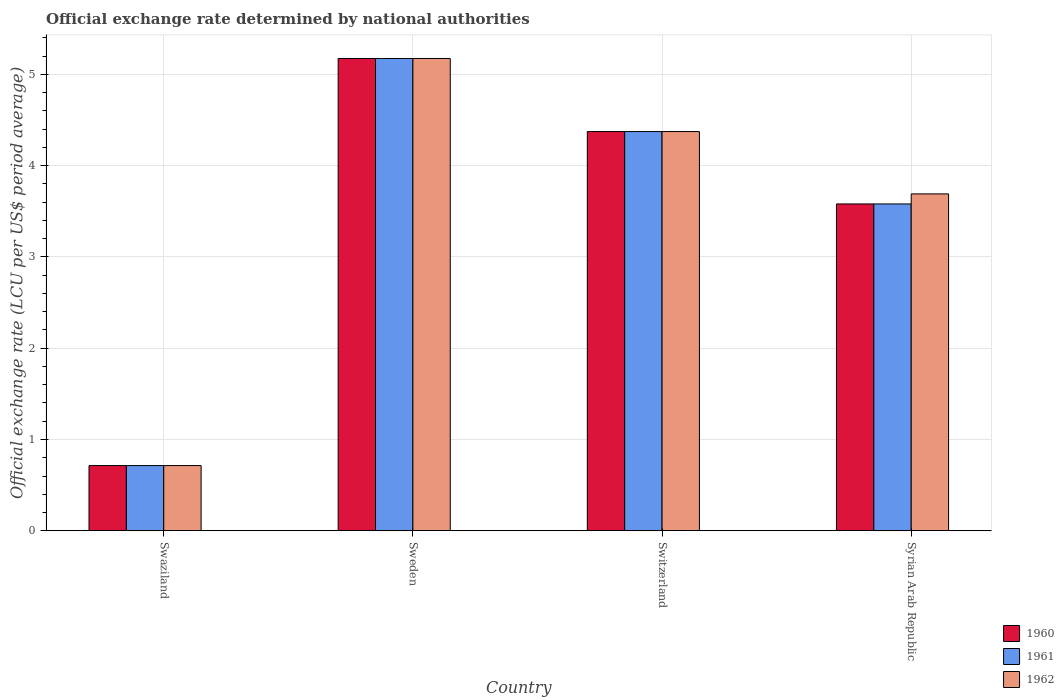Are the number of bars on each tick of the X-axis equal?
Give a very brief answer. Yes. How many bars are there on the 1st tick from the left?
Give a very brief answer. 3. How many bars are there on the 2nd tick from the right?
Give a very brief answer. 3. What is the official exchange rate in 1961 in Switzerland?
Provide a short and direct response. 4.37. Across all countries, what is the maximum official exchange rate in 1960?
Your answer should be very brief. 5.17. Across all countries, what is the minimum official exchange rate in 1961?
Your answer should be very brief. 0.71. In which country was the official exchange rate in 1960 minimum?
Offer a very short reply. Swaziland. What is the total official exchange rate in 1960 in the graph?
Your response must be concise. 13.84. What is the difference between the official exchange rate in 1960 in Sweden and that in Switzerland?
Ensure brevity in your answer.  0.8. What is the difference between the official exchange rate in 1961 in Switzerland and the official exchange rate in 1960 in Swaziland?
Keep it short and to the point. 3.66. What is the average official exchange rate in 1962 per country?
Provide a short and direct response. 3.49. In how many countries, is the official exchange rate in 1962 greater than 2.6 LCU?
Offer a very short reply. 3. What is the ratio of the official exchange rate in 1962 in Switzerland to that in Syrian Arab Republic?
Offer a very short reply. 1.19. Is the difference between the official exchange rate in 1961 in Swaziland and Syrian Arab Republic greater than the difference between the official exchange rate in 1962 in Swaziland and Syrian Arab Republic?
Provide a short and direct response. Yes. What is the difference between the highest and the second highest official exchange rate in 1960?
Ensure brevity in your answer.  -0.79. What is the difference between the highest and the lowest official exchange rate in 1961?
Offer a very short reply. 4.46. Is the sum of the official exchange rate in 1960 in Switzerland and Syrian Arab Republic greater than the maximum official exchange rate in 1962 across all countries?
Give a very brief answer. Yes. What does the 3rd bar from the left in Sweden represents?
Offer a terse response. 1962. What does the 2nd bar from the right in Syrian Arab Republic represents?
Your answer should be very brief. 1961. Is it the case that in every country, the sum of the official exchange rate in 1960 and official exchange rate in 1962 is greater than the official exchange rate in 1961?
Your answer should be very brief. Yes. How many countries are there in the graph?
Your response must be concise. 4. Does the graph contain any zero values?
Give a very brief answer. No. Where does the legend appear in the graph?
Offer a very short reply. Bottom right. What is the title of the graph?
Your answer should be compact. Official exchange rate determined by national authorities. What is the label or title of the X-axis?
Ensure brevity in your answer.  Country. What is the label or title of the Y-axis?
Keep it short and to the point. Official exchange rate (LCU per US$ period average). What is the Official exchange rate (LCU per US$ period average) in 1960 in Swaziland?
Provide a short and direct response. 0.71. What is the Official exchange rate (LCU per US$ period average) of 1961 in Swaziland?
Your response must be concise. 0.71. What is the Official exchange rate (LCU per US$ period average) in 1962 in Swaziland?
Keep it short and to the point. 0.71. What is the Official exchange rate (LCU per US$ period average) of 1960 in Sweden?
Make the answer very short. 5.17. What is the Official exchange rate (LCU per US$ period average) in 1961 in Sweden?
Give a very brief answer. 5.17. What is the Official exchange rate (LCU per US$ period average) of 1962 in Sweden?
Give a very brief answer. 5.17. What is the Official exchange rate (LCU per US$ period average) in 1960 in Switzerland?
Keep it short and to the point. 4.37. What is the Official exchange rate (LCU per US$ period average) in 1961 in Switzerland?
Keep it short and to the point. 4.37. What is the Official exchange rate (LCU per US$ period average) in 1962 in Switzerland?
Your response must be concise. 4.37. What is the Official exchange rate (LCU per US$ period average) of 1960 in Syrian Arab Republic?
Your answer should be compact. 3.58. What is the Official exchange rate (LCU per US$ period average) in 1961 in Syrian Arab Republic?
Offer a terse response. 3.58. What is the Official exchange rate (LCU per US$ period average) of 1962 in Syrian Arab Republic?
Offer a very short reply. 3.69. Across all countries, what is the maximum Official exchange rate (LCU per US$ period average) in 1960?
Offer a terse response. 5.17. Across all countries, what is the maximum Official exchange rate (LCU per US$ period average) of 1961?
Your answer should be compact. 5.17. Across all countries, what is the maximum Official exchange rate (LCU per US$ period average) in 1962?
Offer a very short reply. 5.17. Across all countries, what is the minimum Official exchange rate (LCU per US$ period average) of 1960?
Your response must be concise. 0.71. Across all countries, what is the minimum Official exchange rate (LCU per US$ period average) in 1961?
Offer a terse response. 0.71. Across all countries, what is the minimum Official exchange rate (LCU per US$ period average) of 1962?
Your answer should be compact. 0.71. What is the total Official exchange rate (LCU per US$ period average) of 1960 in the graph?
Your answer should be compact. 13.84. What is the total Official exchange rate (LCU per US$ period average) in 1961 in the graph?
Offer a terse response. 13.84. What is the total Official exchange rate (LCU per US$ period average) of 1962 in the graph?
Give a very brief answer. 13.95. What is the difference between the Official exchange rate (LCU per US$ period average) of 1960 in Swaziland and that in Sweden?
Offer a terse response. -4.46. What is the difference between the Official exchange rate (LCU per US$ period average) of 1961 in Swaziland and that in Sweden?
Offer a terse response. -4.46. What is the difference between the Official exchange rate (LCU per US$ period average) in 1962 in Swaziland and that in Sweden?
Make the answer very short. -4.46. What is the difference between the Official exchange rate (LCU per US$ period average) in 1960 in Swaziland and that in Switzerland?
Offer a terse response. -3.66. What is the difference between the Official exchange rate (LCU per US$ period average) of 1961 in Swaziland and that in Switzerland?
Provide a succinct answer. -3.66. What is the difference between the Official exchange rate (LCU per US$ period average) in 1962 in Swaziland and that in Switzerland?
Your response must be concise. -3.66. What is the difference between the Official exchange rate (LCU per US$ period average) in 1960 in Swaziland and that in Syrian Arab Republic?
Offer a very short reply. -2.87. What is the difference between the Official exchange rate (LCU per US$ period average) of 1961 in Swaziland and that in Syrian Arab Republic?
Provide a succinct answer. -2.87. What is the difference between the Official exchange rate (LCU per US$ period average) in 1962 in Swaziland and that in Syrian Arab Republic?
Offer a very short reply. -2.98. What is the difference between the Official exchange rate (LCU per US$ period average) in 1960 in Sweden and that in Switzerland?
Make the answer very short. 0.8. What is the difference between the Official exchange rate (LCU per US$ period average) of 1961 in Sweden and that in Switzerland?
Give a very brief answer. 0.8. What is the difference between the Official exchange rate (LCU per US$ period average) of 1962 in Sweden and that in Switzerland?
Keep it short and to the point. 0.8. What is the difference between the Official exchange rate (LCU per US$ period average) of 1960 in Sweden and that in Syrian Arab Republic?
Provide a short and direct response. 1.59. What is the difference between the Official exchange rate (LCU per US$ period average) of 1961 in Sweden and that in Syrian Arab Republic?
Make the answer very short. 1.59. What is the difference between the Official exchange rate (LCU per US$ period average) in 1962 in Sweden and that in Syrian Arab Republic?
Provide a short and direct response. 1.48. What is the difference between the Official exchange rate (LCU per US$ period average) of 1960 in Switzerland and that in Syrian Arab Republic?
Offer a terse response. 0.79. What is the difference between the Official exchange rate (LCU per US$ period average) in 1961 in Switzerland and that in Syrian Arab Republic?
Make the answer very short. 0.79. What is the difference between the Official exchange rate (LCU per US$ period average) in 1962 in Switzerland and that in Syrian Arab Republic?
Your response must be concise. 0.68. What is the difference between the Official exchange rate (LCU per US$ period average) of 1960 in Swaziland and the Official exchange rate (LCU per US$ period average) of 1961 in Sweden?
Give a very brief answer. -4.46. What is the difference between the Official exchange rate (LCU per US$ period average) in 1960 in Swaziland and the Official exchange rate (LCU per US$ period average) in 1962 in Sweden?
Your answer should be very brief. -4.46. What is the difference between the Official exchange rate (LCU per US$ period average) of 1961 in Swaziland and the Official exchange rate (LCU per US$ period average) of 1962 in Sweden?
Give a very brief answer. -4.46. What is the difference between the Official exchange rate (LCU per US$ period average) of 1960 in Swaziland and the Official exchange rate (LCU per US$ period average) of 1961 in Switzerland?
Offer a terse response. -3.66. What is the difference between the Official exchange rate (LCU per US$ period average) in 1960 in Swaziland and the Official exchange rate (LCU per US$ period average) in 1962 in Switzerland?
Give a very brief answer. -3.66. What is the difference between the Official exchange rate (LCU per US$ period average) in 1961 in Swaziland and the Official exchange rate (LCU per US$ period average) in 1962 in Switzerland?
Your answer should be very brief. -3.66. What is the difference between the Official exchange rate (LCU per US$ period average) in 1960 in Swaziland and the Official exchange rate (LCU per US$ period average) in 1961 in Syrian Arab Republic?
Offer a very short reply. -2.87. What is the difference between the Official exchange rate (LCU per US$ period average) in 1960 in Swaziland and the Official exchange rate (LCU per US$ period average) in 1962 in Syrian Arab Republic?
Provide a short and direct response. -2.98. What is the difference between the Official exchange rate (LCU per US$ period average) in 1961 in Swaziland and the Official exchange rate (LCU per US$ period average) in 1962 in Syrian Arab Republic?
Your answer should be very brief. -2.98. What is the difference between the Official exchange rate (LCU per US$ period average) in 1960 in Sweden and the Official exchange rate (LCU per US$ period average) in 1961 in Switzerland?
Give a very brief answer. 0.8. What is the difference between the Official exchange rate (LCU per US$ period average) of 1960 in Sweden and the Official exchange rate (LCU per US$ period average) of 1962 in Switzerland?
Make the answer very short. 0.8. What is the difference between the Official exchange rate (LCU per US$ period average) in 1961 in Sweden and the Official exchange rate (LCU per US$ period average) in 1962 in Switzerland?
Provide a succinct answer. 0.8. What is the difference between the Official exchange rate (LCU per US$ period average) in 1960 in Sweden and the Official exchange rate (LCU per US$ period average) in 1961 in Syrian Arab Republic?
Keep it short and to the point. 1.59. What is the difference between the Official exchange rate (LCU per US$ period average) of 1960 in Sweden and the Official exchange rate (LCU per US$ period average) of 1962 in Syrian Arab Republic?
Your answer should be compact. 1.48. What is the difference between the Official exchange rate (LCU per US$ period average) of 1961 in Sweden and the Official exchange rate (LCU per US$ period average) of 1962 in Syrian Arab Republic?
Give a very brief answer. 1.48. What is the difference between the Official exchange rate (LCU per US$ period average) of 1960 in Switzerland and the Official exchange rate (LCU per US$ period average) of 1961 in Syrian Arab Republic?
Your answer should be very brief. 0.79. What is the difference between the Official exchange rate (LCU per US$ period average) in 1960 in Switzerland and the Official exchange rate (LCU per US$ period average) in 1962 in Syrian Arab Republic?
Give a very brief answer. 0.68. What is the difference between the Official exchange rate (LCU per US$ period average) in 1961 in Switzerland and the Official exchange rate (LCU per US$ period average) in 1962 in Syrian Arab Republic?
Your response must be concise. 0.68. What is the average Official exchange rate (LCU per US$ period average) in 1960 per country?
Provide a succinct answer. 3.46. What is the average Official exchange rate (LCU per US$ period average) in 1961 per country?
Give a very brief answer. 3.46. What is the average Official exchange rate (LCU per US$ period average) in 1962 per country?
Ensure brevity in your answer.  3.49. What is the difference between the Official exchange rate (LCU per US$ period average) of 1960 and Official exchange rate (LCU per US$ period average) of 1961 in Swaziland?
Ensure brevity in your answer.  0. What is the difference between the Official exchange rate (LCU per US$ period average) in 1961 and Official exchange rate (LCU per US$ period average) in 1962 in Swaziland?
Provide a short and direct response. 0. What is the difference between the Official exchange rate (LCU per US$ period average) of 1960 and Official exchange rate (LCU per US$ period average) of 1961 in Sweden?
Ensure brevity in your answer.  0. What is the difference between the Official exchange rate (LCU per US$ period average) in 1960 and Official exchange rate (LCU per US$ period average) in 1961 in Syrian Arab Republic?
Ensure brevity in your answer.  0. What is the difference between the Official exchange rate (LCU per US$ period average) in 1960 and Official exchange rate (LCU per US$ period average) in 1962 in Syrian Arab Republic?
Keep it short and to the point. -0.11. What is the difference between the Official exchange rate (LCU per US$ period average) of 1961 and Official exchange rate (LCU per US$ period average) of 1962 in Syrian Arab Republic?
Your answer should be very brief. -0.11. What is the ratio of the Official exchange rate (LCU per US$ period average) of 1960 in Swaziland to that in Sweden?
Keep it short and to the point. 0.14. What is the ratio of the Official exchange rate (LCU per US$ period average) of 1961 in Swaziland to that in Sweden?
Ensure brevity in your answer.  0.14. What is the ratio of the Official exchange rate (LCU per US$ period average) in 1962 in Swaziland to that in Sweden?
Provide a succinct answer. 0.14. What is the ratio of the Official exchange rate (LCU per US$ period average) in 1960 in Swaziland to that in Switzerland?
Your answer should be compact. 0.16. What is the ratio of the Official exchange rate (LCU per US$ period average) of 1961 in Swaziland to that in Switzerland?
Provide a short and direct response. 0.16. What is the ratio of the Official exchange rate (LCU per US$ period average) in 1962 in Swaziland to that in Switzerland?
Make the answer very short. 0.16. What is the ratio of the Official exchange rate (LCU per US$ period average) in 1960 in Swaziland to that in Syrian Arab Republic?
Keep it short and to the point. 0.2. What is the ratio of the Official exchange rate (LCU per US$ period average) in 1961 in Swaziland to that in Syrian Arab Republic?
Provide a short and direct response. 0.2. What is the ratio of the Official exchange rate (LCU per US$ period average) in 1962 in Swaziland to that in Syrian Arab Republic?
Give a very brief answer. 0.19. What is the ratio of the Official exchange rate (LCU per US$ period average) in 1960 in Sweden to that in Switzerland?
Offer a very short reply. 1.18. What is the ratio of the Official exchange rate (LCU per US$ period average) in 1961 in Sweden to that in Switzerland?
Your answer should be very brief. 1.18. What is the ratio of the Official exchange rate (LCU per US$ period average) of 1962 in Sweden to that in Switzerland?
Your response must be concise. 1.18. What is the ratio of the Official exchange rate (LCU per US$ period average) in 1960 in Sweden to that in Syrian Arab Republic?
Your answer should be compact. 1.45. What is the ratio of the Official exchange rate (LCU per US$ period average) of 1961 in Sweden to that in Syrian Arab Republic?
Keep it short and to the point. 1.45. What is the ratio of the Official exchange rate (LCU per US$ period average) of 1962 in Sweden to that in Syrian Arab Republic?
Your answer should be very brief. 1.4. What is the ratio of the Official exchange rate (LCU per US$ period average) of 1960 in Switzerland to that in Syrian Arab Republic?
Offer a very short reply. 1.22. What is the ratio of the Official exchange rate (LCU per US$ period average) of 1961 in Switzerland to that in Syrian Arab Republic?
Make the answer very short. 1.22. What is the ratio of the Official exchange rate (LCU per US$ period average) of 1962 in Switzerland to that in Syrian Arab Republic?
Your answer should be very brief. 1.19. What is the difference between the highest and the second highest Official exchange rate (LCU per US$ period average) in 1960?
Provide a short and direct response. 0.8. What is the difference between the highest and the second highest Official exchange rate (LCU per US$ period average) of 1961?
Provide a succinct answer. 0.8. What is the difference between the highest and the second highest Official exchange rate (LCU per US$ period average) in 1962?
Keep it short and to the point. 0.8. What is the difference between the highest and the lowest Official exchange rate (LCU per US$ period average) in 1960?
Offer a terse response. 4.46. What is the difference between the highest and the lowest Official exchange rate (LCU per US$ period average) in 1961?
Offer a very short reply. 4.46. What is the difference between the highest and the lowest Official exchange rate (LCU per US$ period average) in 1962?
Provide a succinct answer. 4.46. 